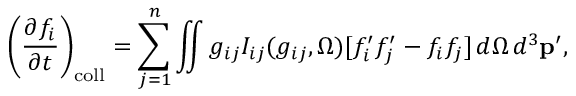<formula> <loc_0><loc_0><loc_500><loc_500>\left ( { \frac { \partial f _ { i } } { \partial t } } \right ) _ { c o l l } = \sum _ { j = 1 } ^ { n } \iint g _ { i j } I _ { i j } ( g _ { i j } , \Omega ) [ f _ { i } ^ { \prime } f _ { j } ^ { \prime } - f _ { i } f _ { j } ] \, d \Omega \, d ^ { 3 } p ^ { \prime } ,</formula> 